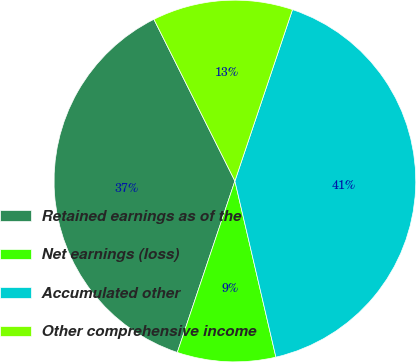Convert chart. <chart><loc_0><loc_0><loc_500><loc_500><pie_chart><fcel>Retained earnings as of the<fcel>Net earnings (loss)<fcel>Accumulated other<fcel>Other comprehensive income<nl><fcel>37.45%<fcel>8.8%<fcel>41.2%<fcel>12.55%<nl></chart> 